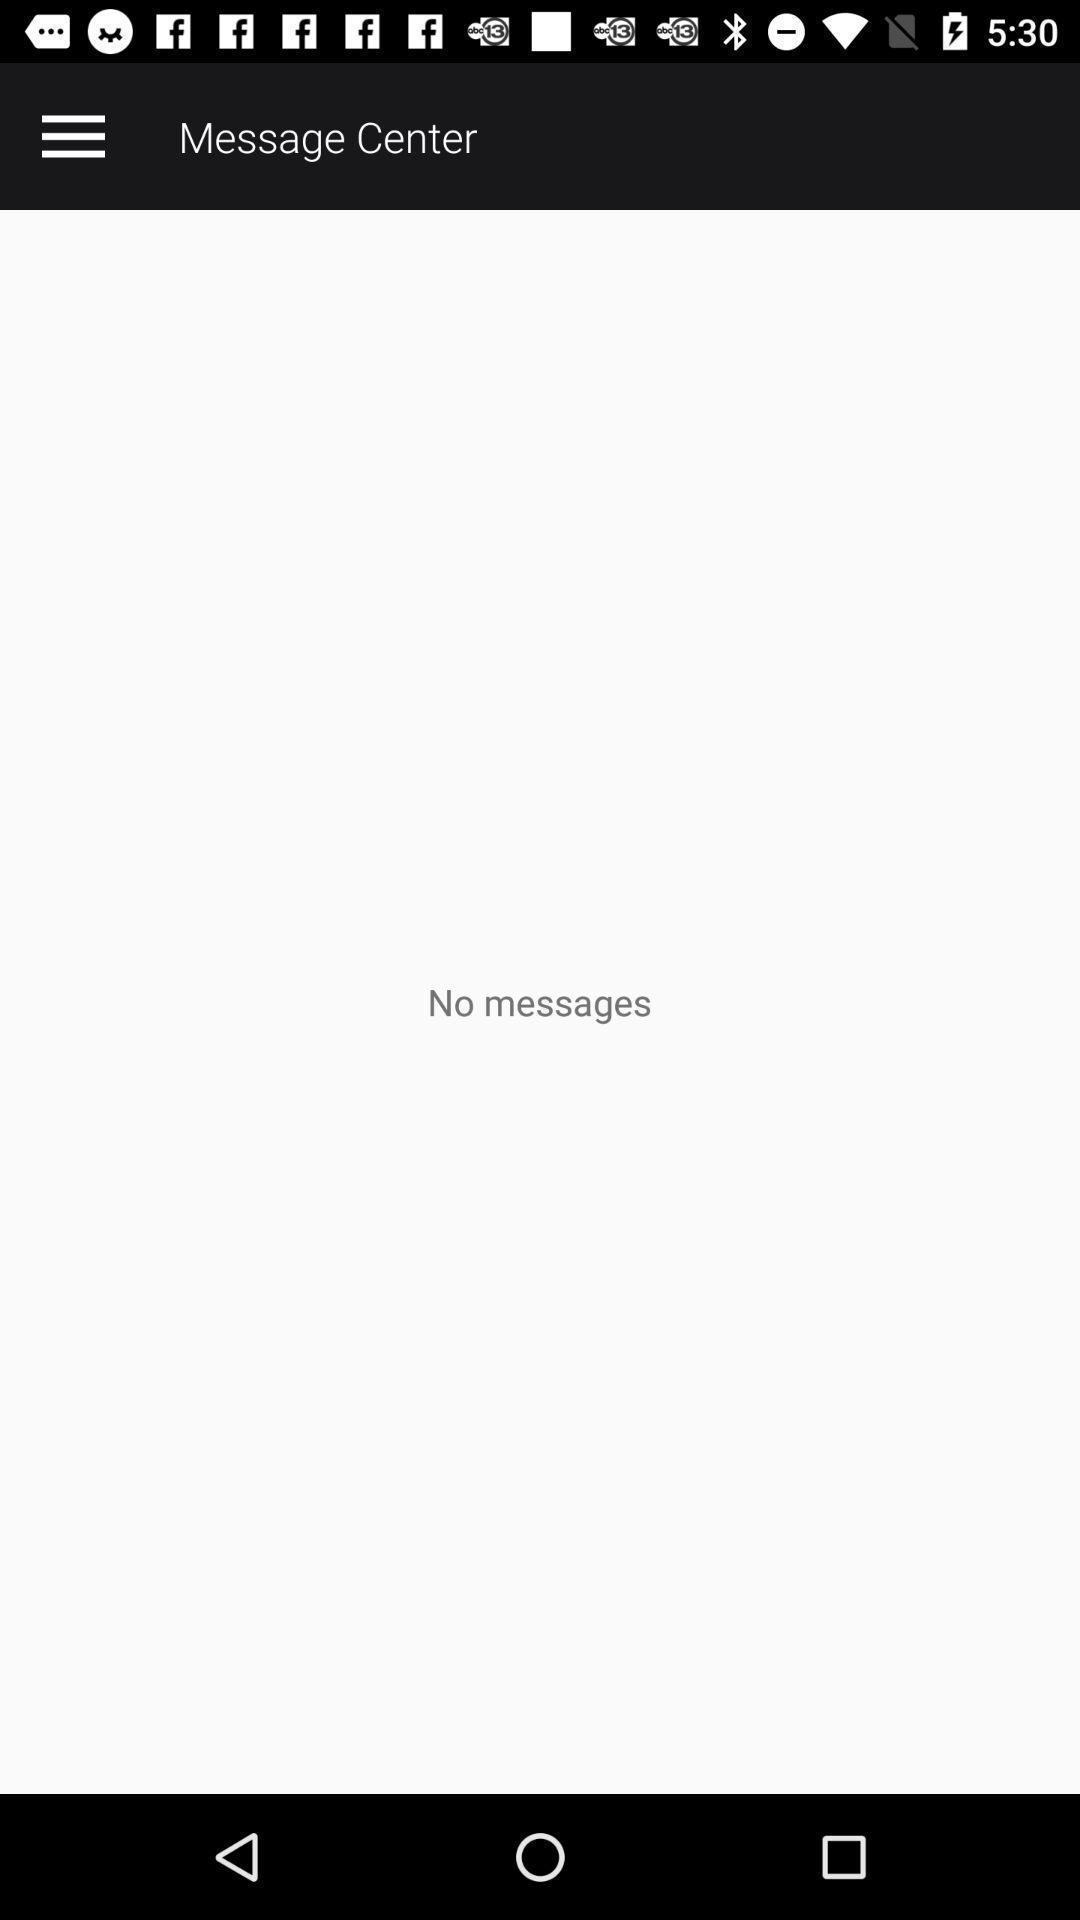Describe the key features of this screenshot. Screen shows no messages in a message center. 